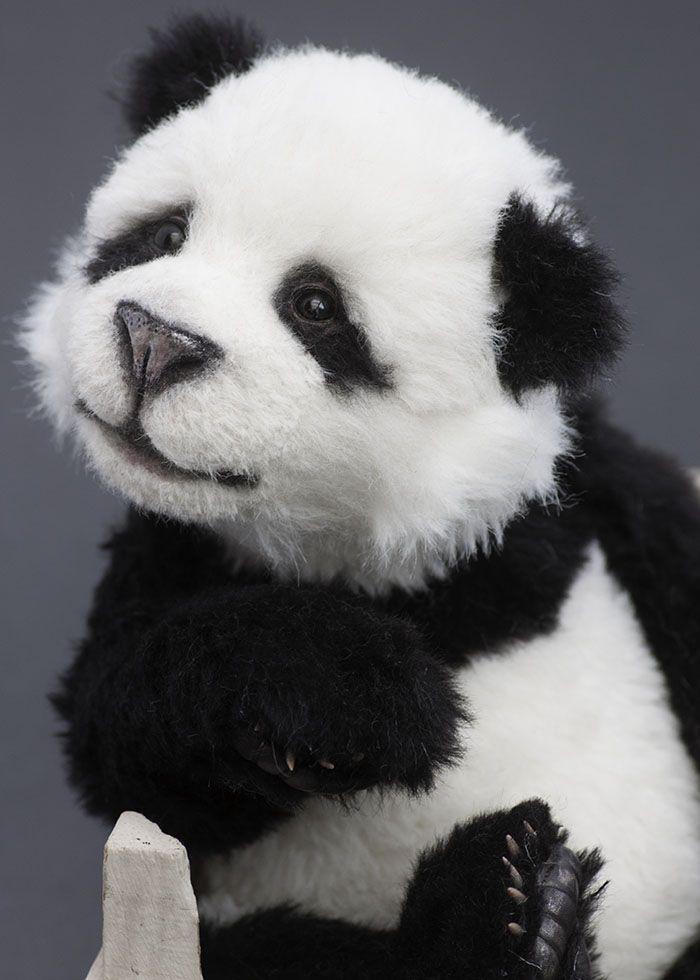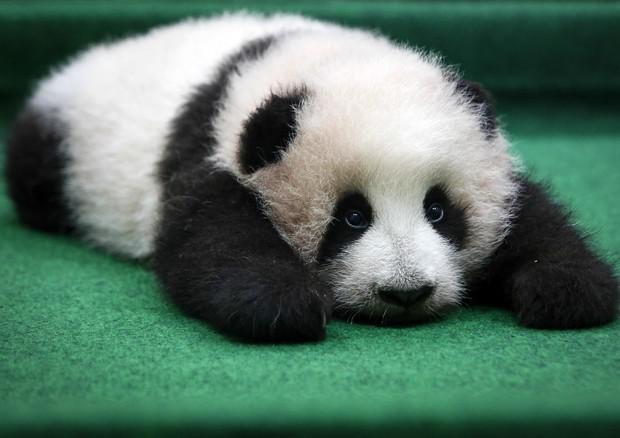The first image is the image on the left, the second image is the image on the right. For the images displayed, is the sentence "A panda has its head on the floor in the right image." factually correct? Answer yes or no. Yes. The first image is the image on the left, the second image is the image on the right. For the images displayed, is the sentence "Two panda faces can be seen, one on top of the other, in one image." factually correct? Answer yes or no. No. 